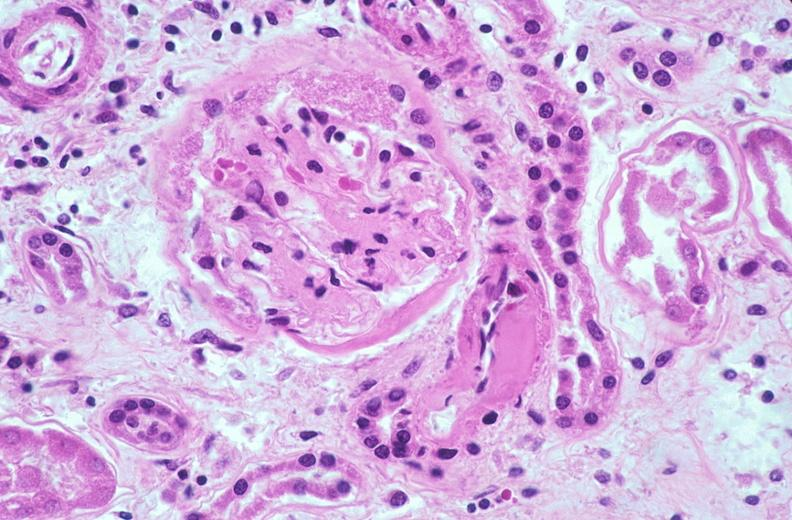where is this?
Answer the question using a single word or phrase. Urinary 